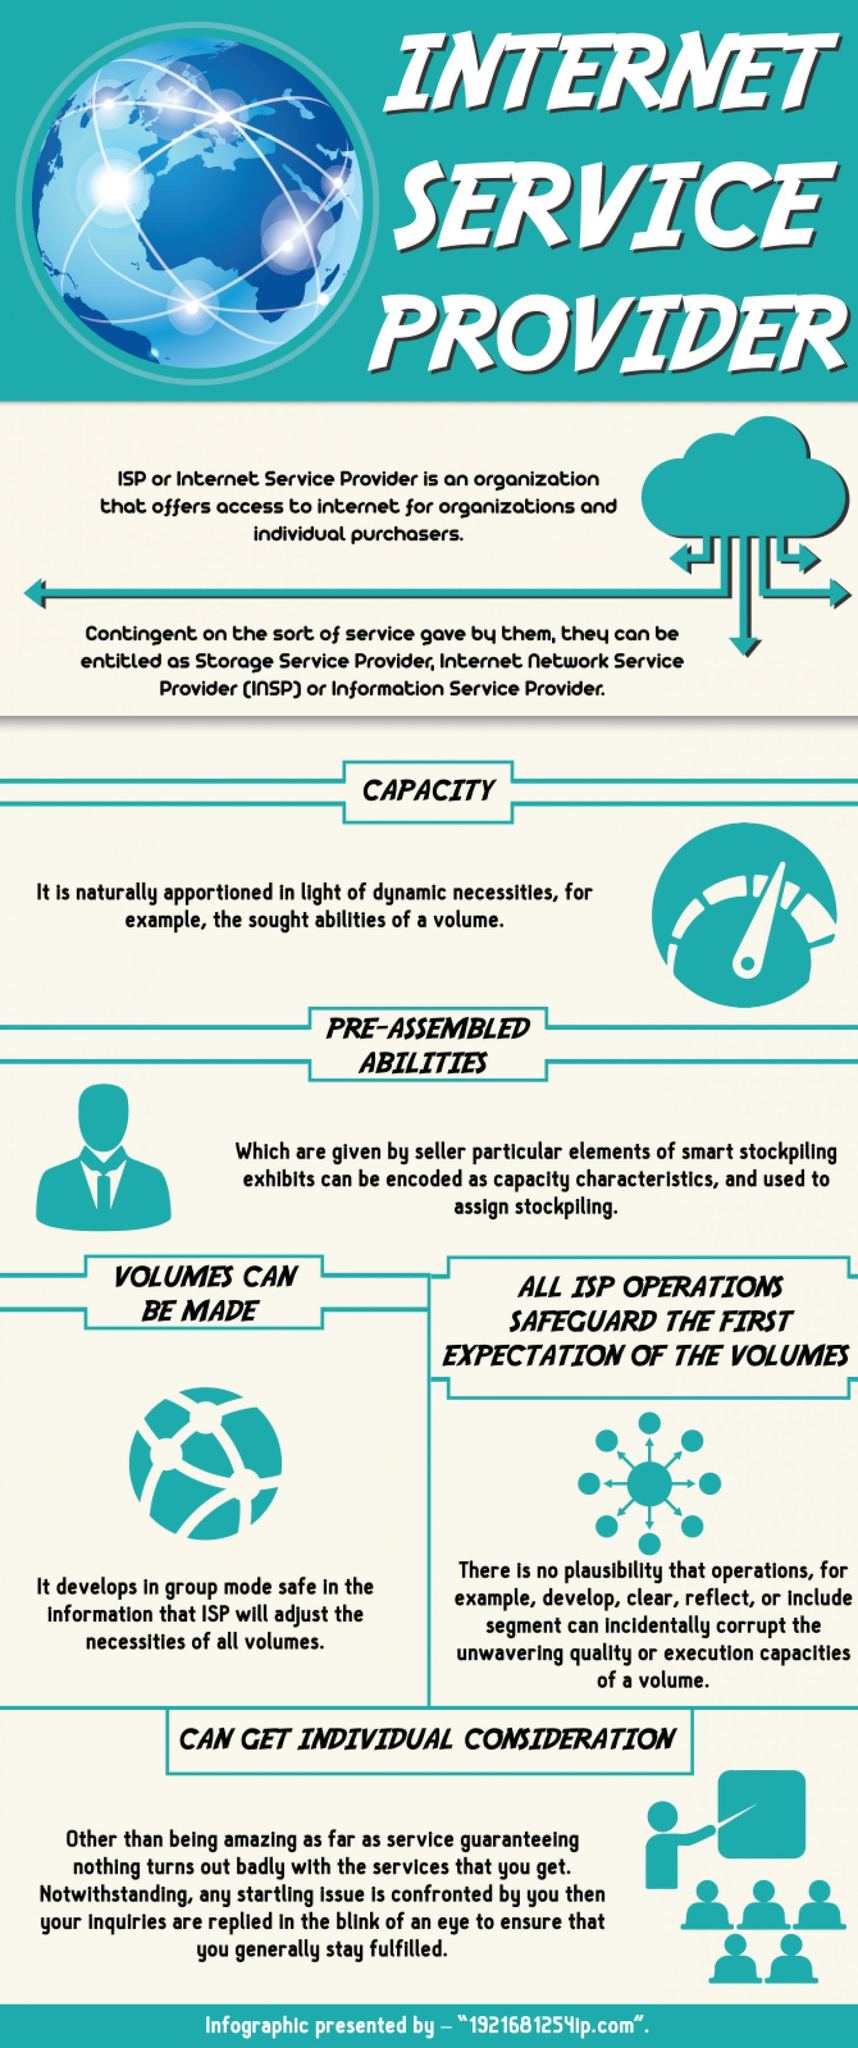Indicate a few pertinent items in this graphic. A service provider can be classified as a storage service provider or an internet network service provider based on the type of service they offer. 